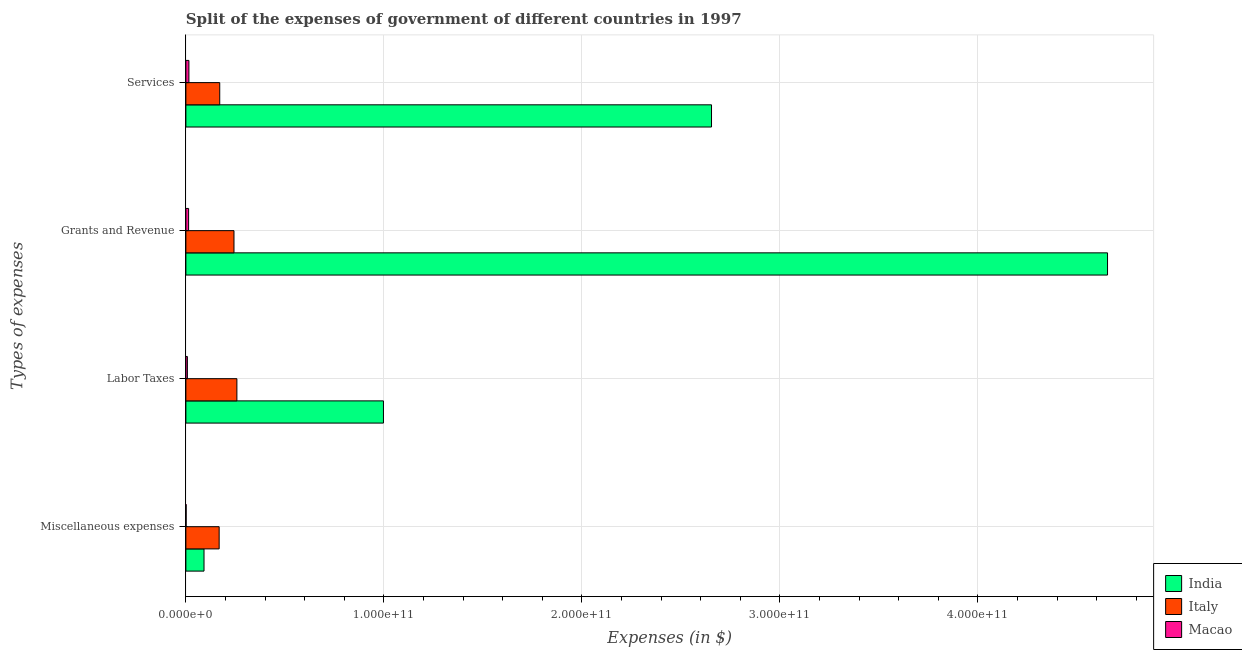How many groups of bars are there?
Ensure brevity in your answer.  4. Are the number of bars on each tick of the Y-axis equal?
Your response must be concise. Yes. How many bars are there on the 4th tick from the bottom?
Keep it short and to the point. 3. What is the label of the 1st group of bars from the top?
Provide a succinct answer. Services. What is the amount spent on miscellaneous expenses in India?
Make the answer very short. 9.16e+09. Across all countries, what is the maximum amount spent on labor taxes?
Offer a very short reply. 9.98e+1. Across all countries, what is the minimum amount spent on services?
Your response must be concise. 1.53e+09. In which country was the amount spent on miscellaneous expenses maximum?
Make the answer very short. Italy. In which country was the amount spent on services minimum?
Your answer should be very brief. Macao. What is the total amount spent on miscellaneous expenses in the graph?
Your answer should be compact. 2.61e+1. What is the difference between the amount spent on services in Italy and that in India?
Provide a short and direct response. -2.48e+11. What is the difference between the amount spent on grants and revenue in Macao and the amount spent on miscellaneous expenses in Italy?
Provide a succinct answer. -1.54e+1. What is the average amount spent on miscellaneous expenses per country?
Your answer should be compact. 8.70e+09. What is the difference between the amount spent on grants and revenue and amount spent on services in India?
Provide a succinct answer. 2.00e+11. What is the ratio of the amount spent on services in India to that in Italy?
Provide a succinct answer. 15.53. Is the difference between the amount spent on labor taxes in Italy and India greater than the difference between the amount spent on miscellaneous expenses in Italy and India?
Provide a short and direct response. No. What is the difference between the highest and the second highest amount spent on miscellaneous expenses?
Make the answer very short. 7.64e+09. What is the difference between the highest and the lowest amount spent on miscellaneous expenses?
Ensure brevity in your answer.  1.67e+1. In how many countries, is the amount spent on grants and revenue greater than the average amount spent on grants and revenue taken over all countries?
Your answer should be compact. 1. Is the sum of the amount spent on grants and revenue in India and Italy greater than the maximum amount spent on labor taxes across all countries?
Keep it short and to the point. Yes. Is it the case that in every country, the sum of the amount spent on services and amount spent on grants and revenue is greater than the sum of amount spent on labor taxes and amount spent on miscellaneous expenses?
Ensure brevity in your answer.  No. What does the 2nd bar from the bottom in Miscellaneous expenses represents?
Your answer should be compact. Italy. How many bars are there?
Ensure brevity in your answer.  12. Are all the bars in the graph horizontal?
Offer a very short reply. Yes. How many countries are there in the graph?
Your response must be concise. 3. What is the difference between two consecutive major ticks on the X-axis?
Give a very brief answer. 1.00e+11. Does the graph contain any zero values?
Give a very brief answer. No. Does the graph contain grids?
Give a very brief answer. Yes. How many legend labels are there?
Offer a very short reply. 3. What is the title of the graph?
Give a very brief answer. Split of the expenses of government of different countries in 1997. Does "South Africa" appear as one of the legend labels in the graph?
Keep it short and to the point. No. What is the label or title of the X-axis?
Offer a very short reply. Expenses (in $). What is the label or title of the Y-axis?
Your answer should be very brief. Types of expenses. What is the Expenses (in $) of India in Miscellaneous expenses?
Your answer should be very brief. 9.16e+09. What is the Expenses (in $) of Italy in Miscellaneous expenses?
Provide a short and direct response. 1.68e+1. What is the Expenses (in $) in Macao in Miscellaneous expenses?
Ensure brevity in your answer.  1.36e+08. What is the Expenses (in $) of India in Labor Taxes?
Keep it short and to the point. 9.98e+1. What is the Expenses (in $) of Italy in Labor Taxes?
Offer a very short reply. 2.58e+1. What is the Expenses (in $) in Macao in Labor Taxes?
Provide a succinct answer. 7.64e+08. What is the Expenses (in $) in India in Grants and Revenue?
Your answer should be very brief. 4.65e+11. What is the Expenses (in $) in Italy in Grants and Revenue?
Provide a short and direct response. 2.43e+1. What is the Expenses (in $) of Macao in Grants and Revenue?
Offer a terse response. 1.38e+09. What is the Expenses (in $) of India in Services?
Provide a succinct answer. 2.65e+11. What is the Expenses (in $) in Italy in Services?
Your response must be concise. 1.71e+1. What is the Expenses (in $) in Macao in Services?
Your response must be concise. 1.53e+09. Across all Types of expenses, what is the maximum Expenses (in $) of India?
Ensure brevity in your answer.  4.65e+11. Across all Types of expenses, what is the maximum Expenses (in $) in Italy?
Keep it short and to the point. 2.58e+1. Across all Types of expenses, what is the maximum Expenses (in $) of Macao?
Ensure brevity in your answer.  1.53e+09. Across all Types of expenses, what is the minimum Expenses (in $) of India?
Provide a short and direct response. 9.16e+09. Across all Types of expenses, what is the minimum Expenses (in $) of Italy?
Provide a succinct answer. 1.68e+1. Across all Types of expenses, what is the minimum Expenses (in $) of Macao?
Provide a succinct answer. 1.36e+08. What is the total Expenses (in $) in India in the graph?
Keep it short and to the point. 8.40e+11. What is the total Expenses (in $) in Italy in the graph?
Keep it short and to the point. 8.40e+1. What is the total Expenses (in $) in Macao in the graph?
Keep it short and to the point. 3.81e+09. What is the difference between the Expenses (in $) in India in Miscellaneous expenses and that in Labor Taxes?
Provide a short and direct response. -9.06e+1. What is the difference between the Expenses (in $) in Italy in Miscellaneous expenses and that in Labor Taxes?
Keep it short and to the point. -8.95e+09. What is the difference between the Expenses (in $) of Macao in Miscellaneous expenses and that in Labor Taxes?
Ensure brevity in your answer.  -6.28e+08. What is the difference between the Expenses (in $) in India in Miscellaneous expenses and that in Grants and Revenue?
Your answer should be very brief. -4.56e+11. What is the difference between the Expenses (in $) in Italy in Miscellaneous expenses and that in Grants and Revenue?
Make the answer very short. -7.49e+09. What is the difference between the Expenses (in $) of Macao in Miscellaneous expenses and that in Grants and Revenue?
Provide a short and direct response. -1.24e+09. What is the difference between the Expenses (in $) of India in Miscellaneous expenses and that in Services?
Your answer should be very brief. -2.56e+11. What is the difference between the Expenses (in $) of Italy in Miscellaneous expenses and that in Services?
Offer a very short reply. -2.90e+08. What is the difference between the Expenses (in $) in Macao in Miscellaneous expenses and that in Services?
Provide a short and direct response. -1.40e+09. What is the difference between the Expenses (in $) in India in Labor Taxes and that in Grants and Revenue?
Make the answer very short. -3.66e+11. What is the difference between the Expenses (in $) of Italy in Labor Taxes and that in Grants and Revenue?
Your response must be concise. 1.46e+09. What is the difference between the Expenses (in $) in Macao in Labor Taxes and that in Grants and Revenue?
Your answer should be very brief. -6.14e+08. What is the difference between the Expenses (in $) of India in Labor Taxes and that in Services?
Ensure brevity in your answer.  -1.66e+11. What is the difference between the Expenses (in $) of Italy in Labor Taxes and that in Services?
Ensure brevity in your answer.  8.66e+09. What is the difference between the Expenses (in $) of Macao in Labor Taxes and that in Services?
Your response must be concise. -7.67e+08. What is the difference between the Expenses (in $) in India in Grants and Revenue and that in Services?
Your response must be concise. 2.00e+11. What is the difference between the Expenses (in $) in Italy in Grants and Revenue and that in Services?
Your response must be concise. 7.20e+09. What is the difference between the Expenses (in $) in Macao in Grants and Revenue and that in Services?
Keep it short and to the point. -1.53e+08. What is the difference between the Expenses (in $) in India in Miscellaneous expenses and the Expenses (in $) in Italy in Labor Taxes?
Offer a very short reply. -1.66e+1. What is the difference between the Expenses (in $) in India in Miscellaneous expenses and the Expenses (in $) in Macao in Labor Taxes?
Offer a very short reply. 8.40e+09. What is the difference between the Expenses (in $) of Italy in Miscellaneous expenses and the Expenses (in $) of Macao in Labor Taxes?
Make the answer very short. 1.60e+1. What is the difference between the Expenses (in $) of India in Miscellaneous expenses and the Expenses (in $) of Italy in Grants and Revenue?
Your answer should be compact. -1.51e+1. What is the difference between the Expenses (in $) of India in Miscellaneous expenses and the Expenses (in $) of Macao in Grants and Revenue?
Offer a very short reply. 7.78e+09. What is the difference between the Expenses (in $) in Italy in Miscellaneous expenses and the Expenses (in $) in Macao in Grants and Revenue?
Your answer should be very brief. 1.54e+1. What is the difference between the Expenses (in $) in India in Miscellaneous expenses and the Expenses (in $) in Italy in Services?
Your answer should be very brief. -7.94e+09. What is the difference between the Expenses (in $) of India in Miscellaneous expenses and the Expenses (in $) of Macao in Services?
Your answer should be very brief. 7.63e+09. What is the difference between the Expenses (in $) in Italy in Miscellaneous expenses and the Expenses (in $) in Macao in Services?
Your answer should be compact. 1.53e+1. What is the difference between the Expenses (in $) in India in Labor Taxes and the Expenses (in $) in Italy in Grants and Revenue?
Offer a terse response. 7.55e+1. What is the difference between the Expenses (in $) of India in Labor Taxes and the Expenses (in $) of Macao in Grants and Revenue?
Make the answer very short. 9.84e+1. What is the difference between the Expenses (in $) in Italy in Labor Taxes and the Expenses (in $) in Macao in Grants and Revenue?
Your answer should be compact. 2.44e+1. What is the difference between the Expenses (in $) in India in Labor Taxes and the Expenses (in $) in Italy in Services?
Your response must be concise. 8.27e+1. What is the difference between the Expenses (in $) in India in Labor Taxes and the Expenses (in $) in Macao in Services?
Ensure brevity in your answer.  9.82e+1. What is the difference between the Expenses (in $) in Italy in Labor Taxes and the Expenses (in $) in Macao in Services?
Your response must be concise. 2.42e+1. What is the difference between the Expenses (in $) in India in Grants and Revenue and the Expenses (in $) in Italy in Services?
Make the answer very short. 4.48e+11. What is the difference between the Expenses (in $) of India in Grants and Revenue and the Expenses (in $) of Macao in Services?
Provide a short and direct response. 4.64e+11. What is the difference between the Expenses (in $) of Italy in Grants and Revenue and the Expenses (in $) of Macao in Services?
Ensure brevity in your answer.  2.28e+1. What is the average Expenses (in $) of India per Types of expenses?
Give a very brief answer. 2.10e+11. What is the average Expenses (in $) in Italy per Types of expenses?
Provide a short and direct response. 2.10e+1. What is the average Expenses (in $) of Macao per Types of expenses?
Your answer should be very brief. 9.53e+08. What is the difference between the Expenses (in $) of India and Expenses (in $) of Italy in Miscellaneous expenses?
Give a very brief answer. -7.64e+09. What is the difference between the Expenses (in $) in India and Expenses (in $) in Macao in Miscellaneous expenses?
Provide a short and direct response. 9.02e+09. What is the difference between the Expenses (in $) of Italy and Expenses (in $) of Macao in Miscellaneous expenses?
Your response must be concise. 1.67e+1. What is the difference between the Expenses (in $) in India and Expenses (in $) in Italy in Labor Taxes?
Make the answer very short. 7.40e+1. What is the difference between the Expenses (in $) in India and Expenses (in $) in Macao in Labor Taxes?
Provide a succinct answer. 9.90e+1. What is the difference between the Expenses (in $) of Italy and Expenses (in $) of Macao in Labor Taxes?
Your answer should be very brief. 2.50e+1. What is the difference between the Expenses (in $) in India and Expenses (in $) in Italy in Grants and Revenue?
Provide a succinct answer. 4.41e+11. What is the difference between the Expenses (in $) in India and Expenses (in $) in Macao in Grants and Revenue?
Provide a succinct answer. 4.64e+11. What is the difference between the Expenses (in $) of Italy and Expenses (in $) of Macao in Grants and Revenue?
Your response must be concise. 2.29e+1. What is the difference between the Expenses (in $) of India and Expenses (in $) of Italy in Services?
Ensure brevity in your answer.  2.48e+11. What is the difference between the Expenses (in $) in India and Expenses (in $) in Macao in Services?
Keep it short and to the point. 2.64e+11. What is the difference between the Expenses (in $) in Italy and Expenses (in $) in Macao in Services?
Provide a succinct answer. 1.56e+1. What is the ratio of the Expenses (in $) in India in Miscellaneous expenses to that in Labor Taxes?
Offer a very short reply. 0.09. What is the ratio of the Expenses (in $) in Italy in Miscellaneous expenses to that in Labor Taxes?
Offer a very short reply. 0.65. What is the ratio of the Expenses (in $) of Macao in Miscellaneous expenses to that in Labor Taxes?
Provide a succinct answer. 0.18. What is the ratio of the Expenses (in $) of India in Miscellaneous expenses to that in Grants and Revenue?
Offer a very short reply. 0.02. What is the ratio of the Expenses (in $) of Italy in Miscellaneous expenses to that in Grants and Revenue?
Offer a terse response. 0.69. What is the ratio of the Expenses (in $) of Macao in Miscellaneous expenses to that in Grants and Revenue?
Ensure brevity in your answer.  0.1. What is the ratio of the Expenses (in $) of India in Miscellaneous expenses to that in Services?
Provide a succinct answer. 0.03. What is the ratio of the Expenses (in $) of Macao in Miscellaneous expenses to that in Services?
Your answer should be compact. 0.09. What is the ratio of the Expenses (in $) of India in Labor Taxes to that in Grants and Revenue?
Your answer should be compact. 0.21. What is the ratio of the Expenses (in $) in Italy in Labor Taxes to that in Grants and Revenue?
Your response must be concise. 1.06. What is the ratio of the Expenses (in $) in Macao in Labor Taxes to that in Grants and Revenue?
Offer a terse response. 0.55. What is the ratio of the Expenses (in $) in India in Labor Taxes to that in Services?
Offer a terse response. 0.38. What is the ratio of the Expenses (in $) in Italy in Labor Taxes to that in Services?
Offer a terse response. 1.51. What is the ratio of the Expenses (in $) in Macao in Labor Taxes to that in Services?
Offer a very short reply. 0.5. What is the ratio of the Expenses (in $) of India in Grants and Revenue to that in Services?
Offer a terse response. 1.75. What is the ratio of the Expenses (in $) in Italy in Grants and Revenue to that in Services?
Offer a very short reply. 1.42. What is the ratio of the Expenses (in $) of Macao in Grants and Revenue to that in Services?
Provide a succinct answer. 0.9. What is the difference between the highest and the second highest Expenses (in $) of India?
Offer a very short reply. 2.00e+11. What is the difference between the highest and the second highest Expenses (in $) in Italy?
Your answer should be compact. 1.46e+09. What is the difference between the highest and the second highest Expenses (in $) of Macao?
Offer a terse response. 1.53e+08. What is the difference between the highest and the lowest Expenses (in $) of India?
Provide a short and direct response. 4.56e+11. What is the difference between the highest and the lowest Expenses (in $) of Italy?
Make the answer very short. 8.95e+09. What is the difference between the highest and the lowest Expenses (in $) in Macao?
Ensure brevity in your answer.  1.40e+09. 